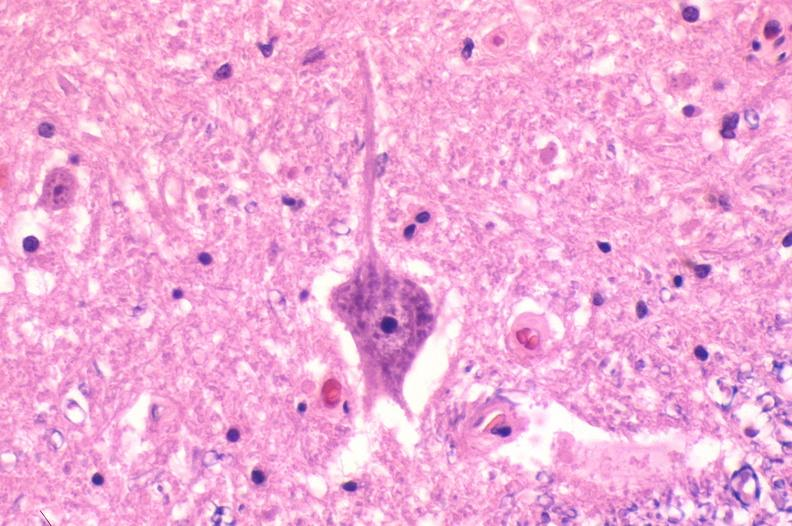does this image show spinal cord injury due to vertebral column trauma, demyelination?
Answer the question using a single word or phrase. Yes 